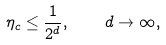Convert formula to latex. <formula><loc_0><loc_0><loc_500><loc_500>\eta _ { c } \leq \frac { 1 } { 2 ^ { d } } , \quad d \rightarrow \infty ,</formula> 